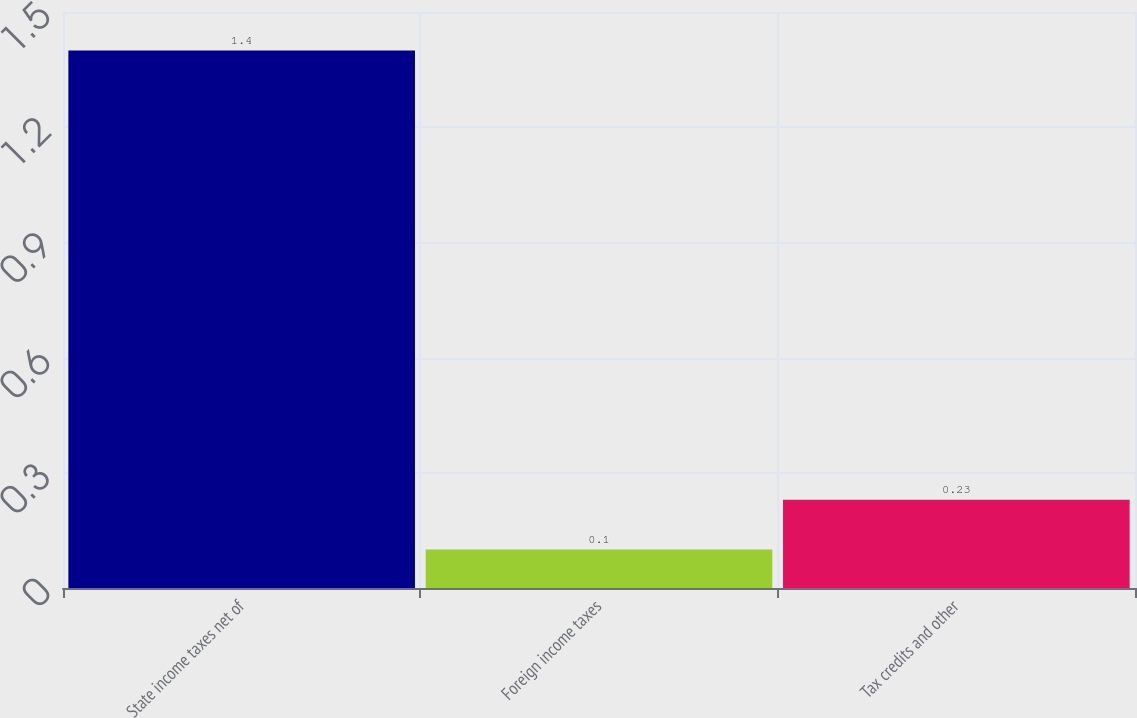<chart> <loc_0><loc_0><loc_500><loc_500><bar_chart><fcel>State income taxes net of<fcel>Foreign income taxes<fcel>Tax credits and other<nl><fcel>1.4<fcel>0.1<fcel>0.23<nl></chart> 